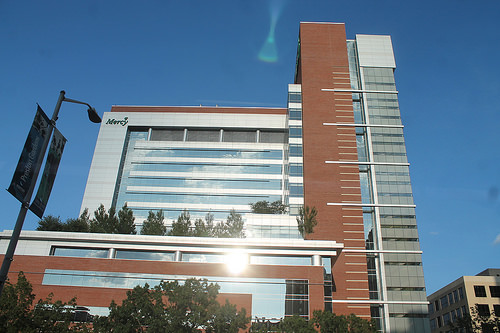<image>
Can you confirm if the tree is on the building? Yes. Looking at the image, I can see the tree is positioned on top of the building, with the building providing support. 